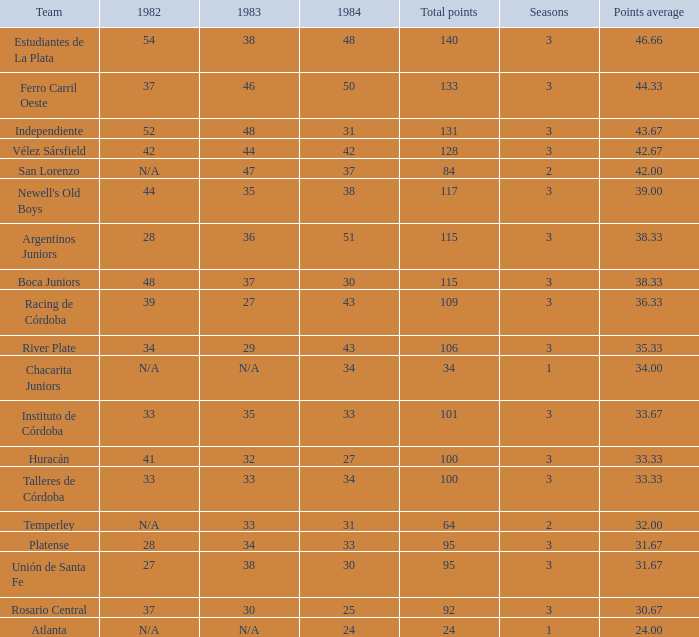What is the sum for 1984 for the team with 100 points in total and more than 3 seasons? None. 